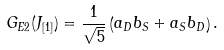Convert formula to latex. <formula><loc_0><loc_0><loc_500><loc_500>G _ { E 2 } ( { J } _ { [ 1 ] } ) = { \frac { 1 } { \sqrt { 5 } } } \left ( a _ { D } b _ { S } + a _ { S } b _ { D } \right ) .</formula> 